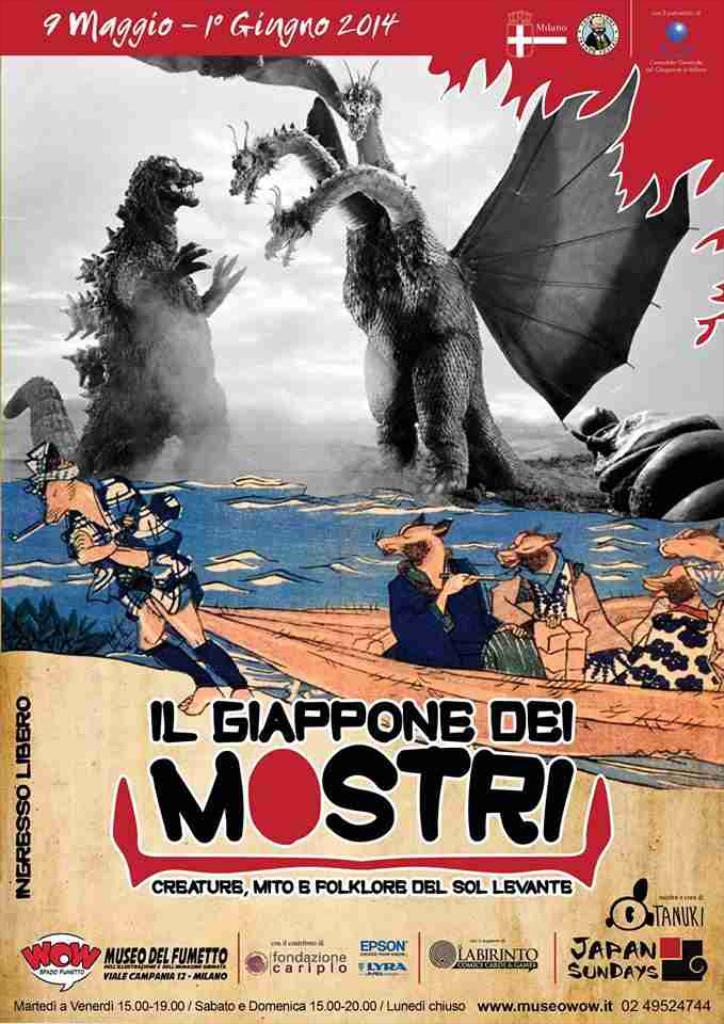Provide a one-sentence caption for the provided image. a movie poster that has Mostri on it. 